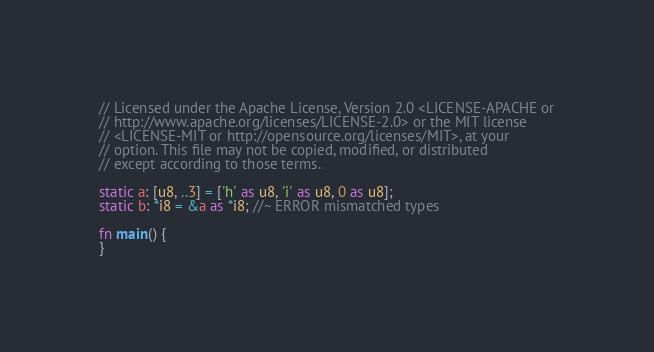Convert code to text. <code><loc_0><loc_0><loc_500><loc_500><_Rust_>// Licensed under the Apache License, Version 2.0 <LICENSE-APACHE or
// http://www.apache.org/licenses/LICENSE-2.0> or the MIT license
// <LICENSE-MIT or http://opensource.org/licenses/MIT>, at your
// option. This file may not be copied, modified, or distributed
// except according to those terms.

static a: [u8, ..3] = ['h' as u8, 'i' as u8, 0 as u8];
static b: *i8 = &a as *i8; //~ ERROR mismatched types

fn main() {
}
</code> 